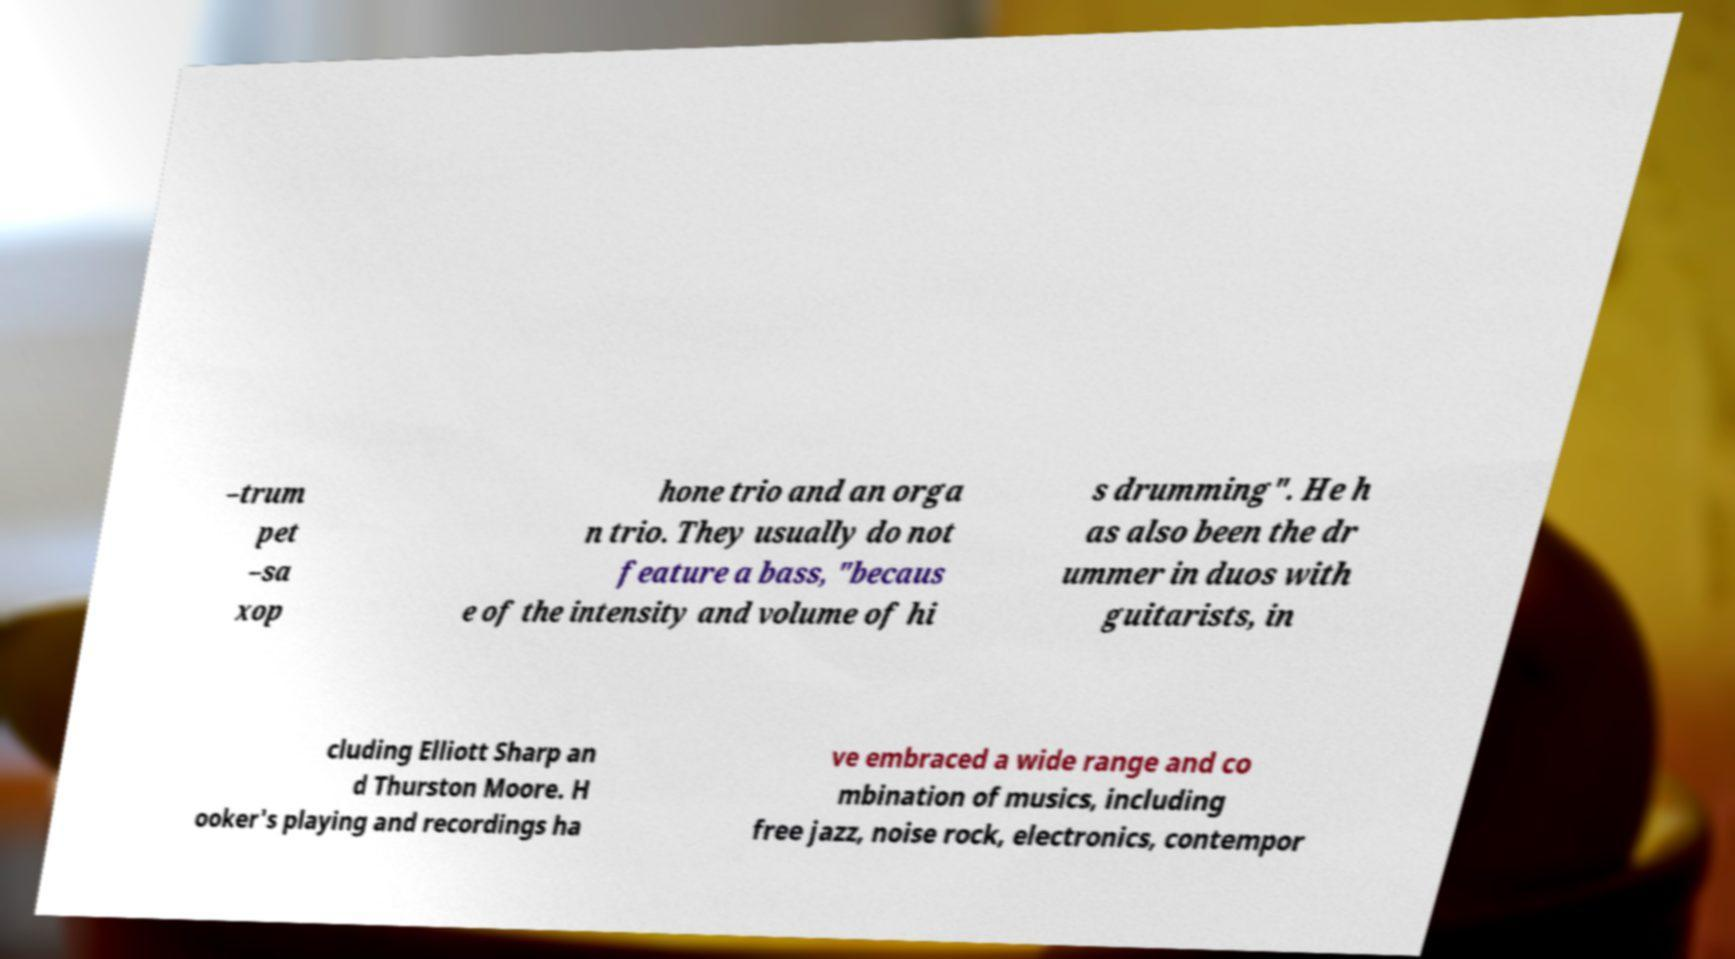What messages or text are displayed in this image? I need them in a readable, typed format. –trum pet –sa xop hone trio and an orga n trio. They usually do not feature a bass, "becaus e of the intensity and volume of hi s drumming". He h as also been the dr ummer in duos with guitarists, in cluding Elliott Sharp an d Thurston Moore. H ooker's playing and recordings ha ve embraced a wide range and co mbination of musics, including free jazz, noise rock, electronics, contempor 